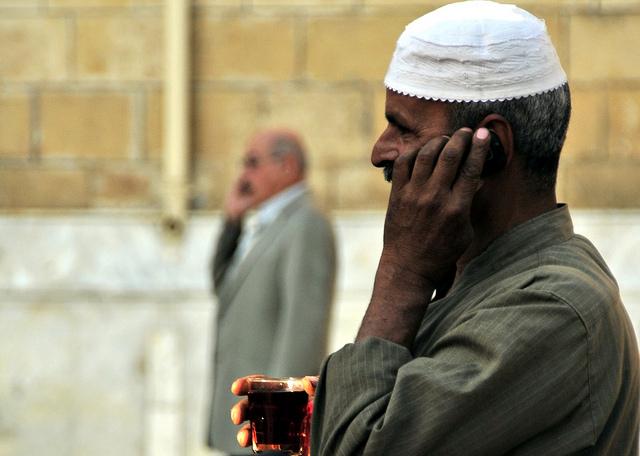Does the man wear glasses?
Answer briefly. No. Which way is the man facing?
Short answer required. Left. What is the man holding in his right hand?
Quick response, please. Drink. 